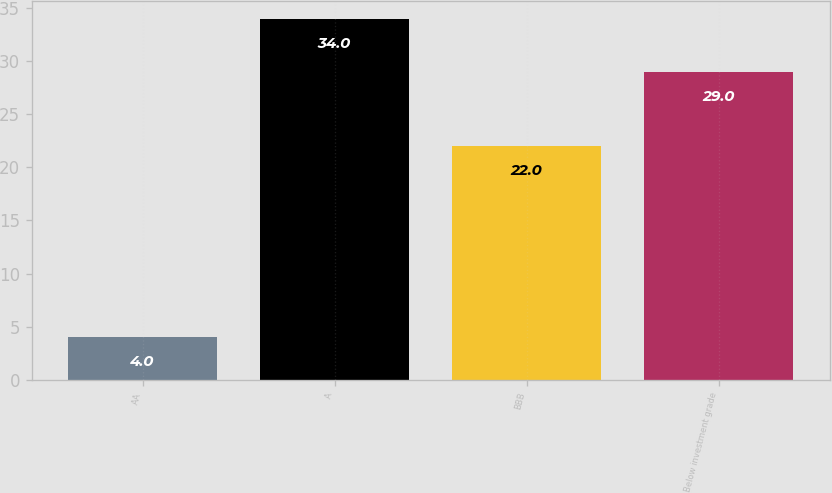<chart> <loc_0><loc_0><loc_500><loc_500><bar_chart><fcel>AA<fcel>A<fcel>BBB<fcel>Below investment grade<nl><fcel>4<fcel>34<fcel>22<fcel>29<nl></chart> 